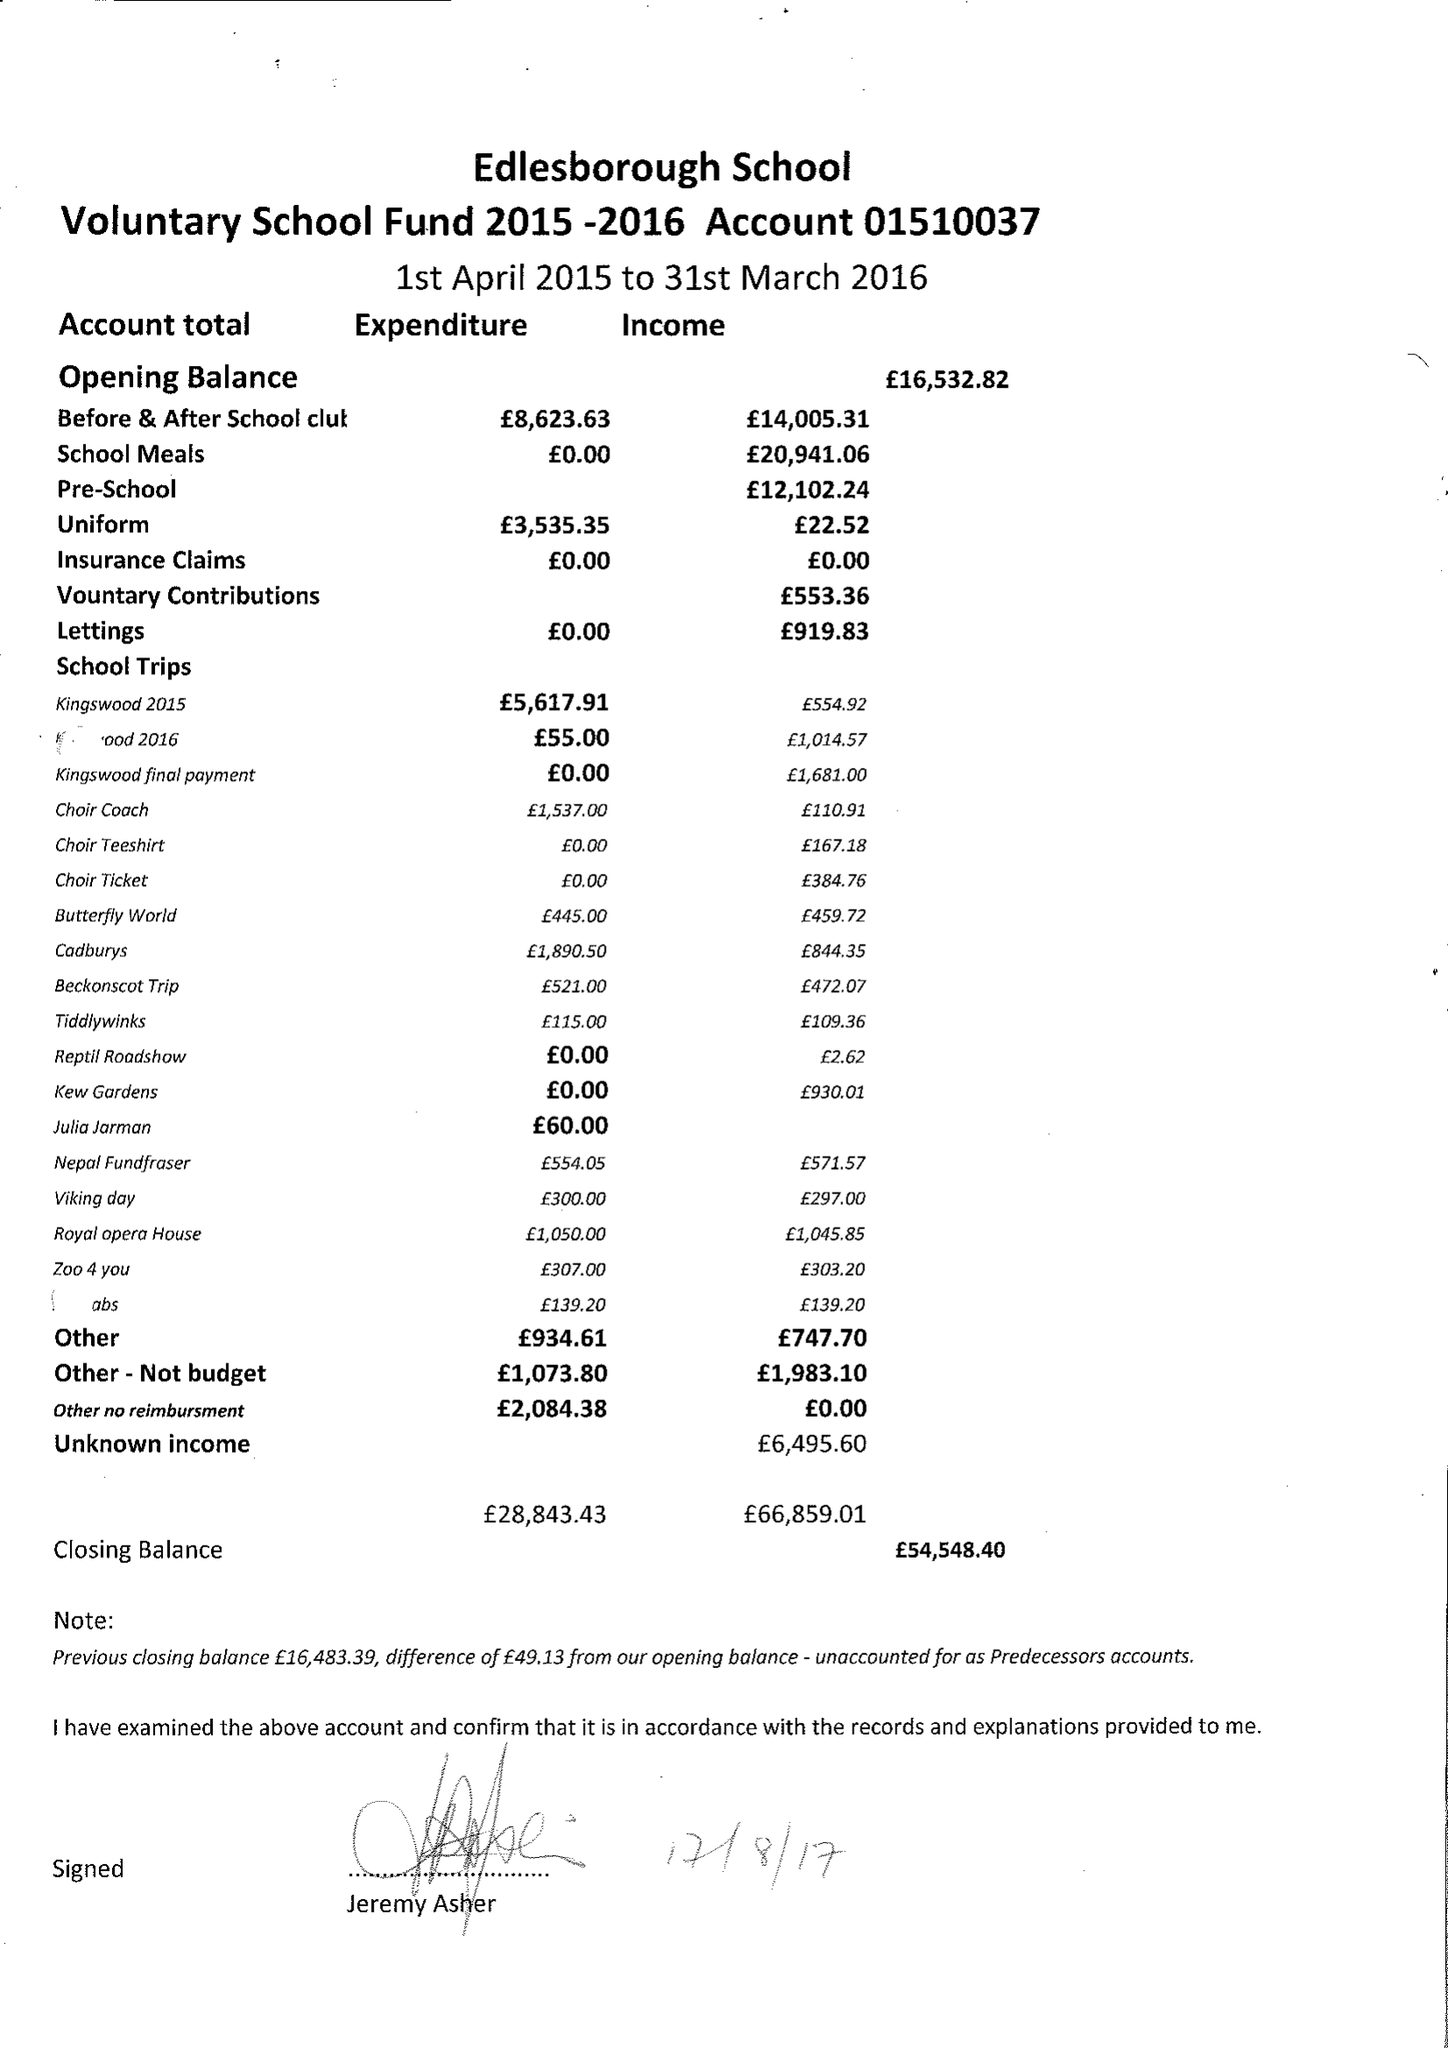What is the value for the address__postcode?
Answer the question using a single word or phrase. LU6 2HS 